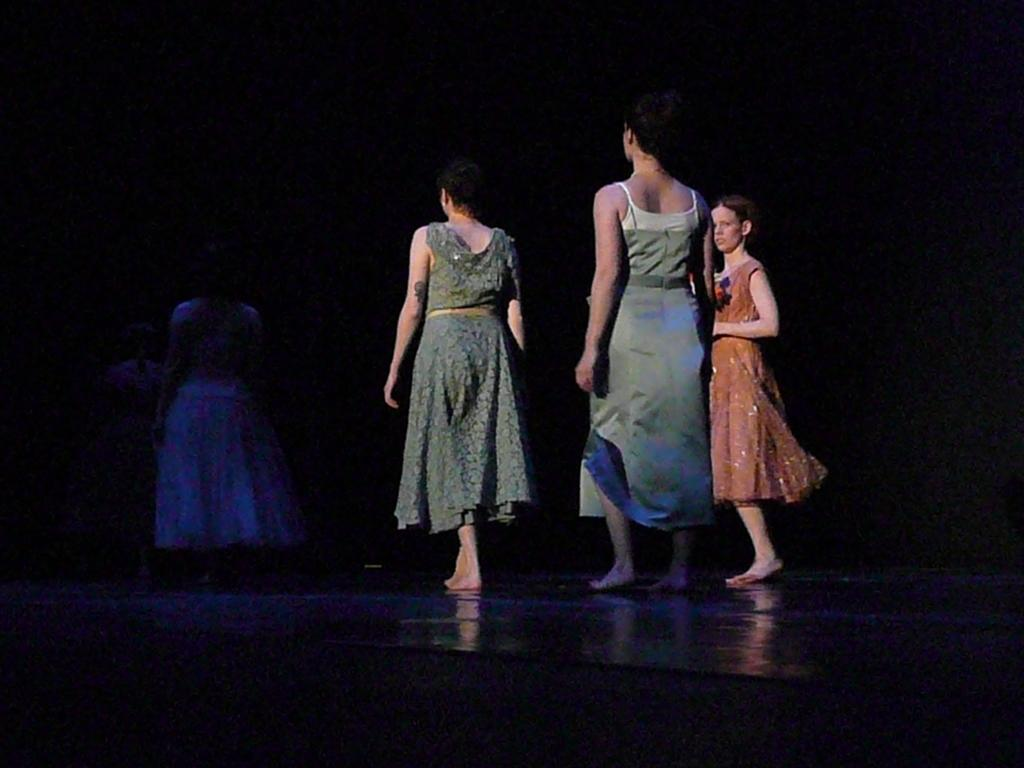What is the main subject of the image? The main subject of the image is a group of people. What are the people in the image doing? The people are standing in the image. How can we differentiate the people in the image? The people are wearing different color dresses. What is the color of the background in the image? The background of the image is black. Can you tell me how many cushions are on the floor in the image? There is no mention of cushions in the image, so it is not possible to answer that question. 